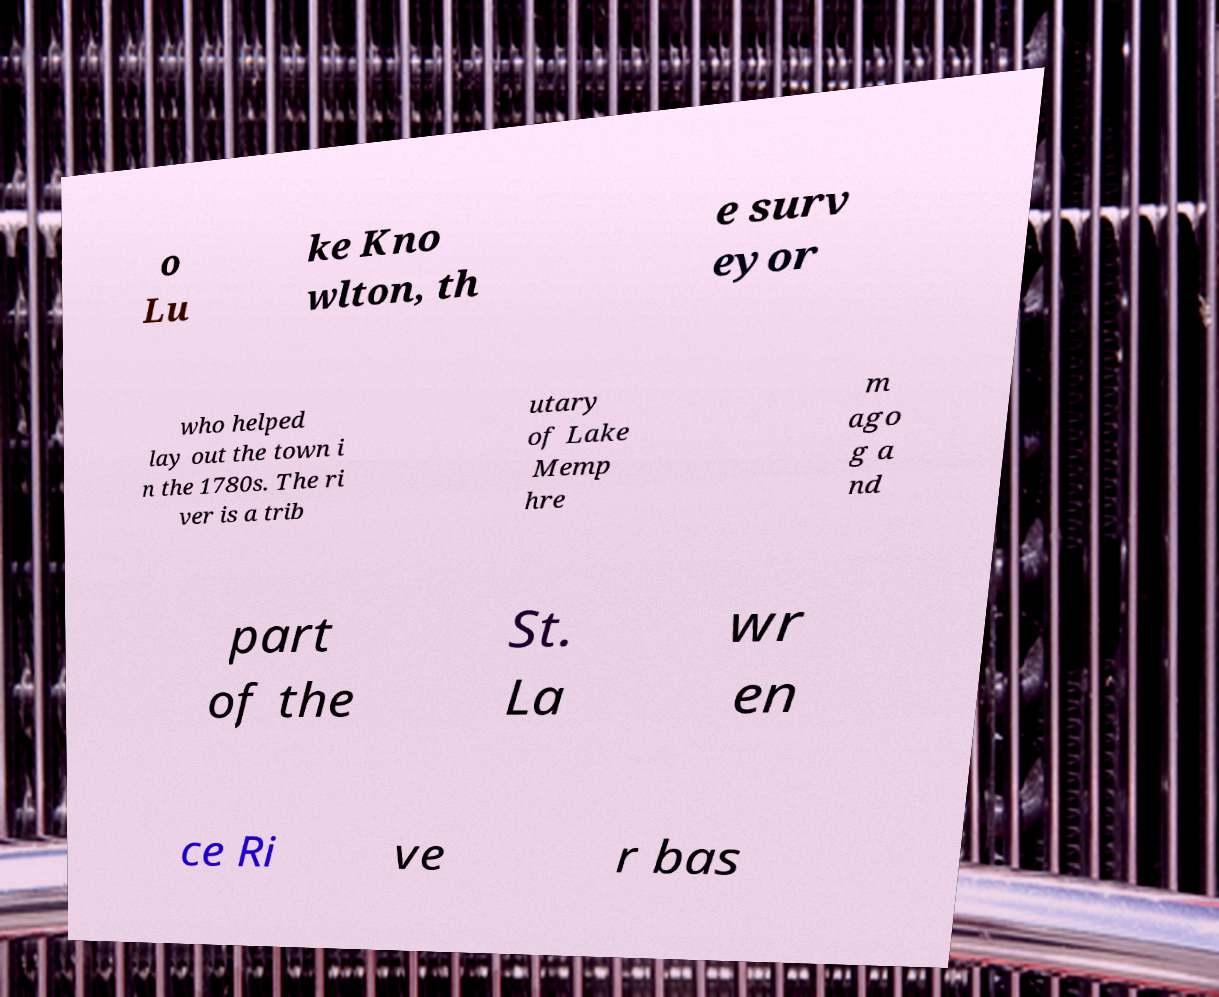Please identify and transcribe the text found in this image. o Lu ke Kno wlton, th e surv eyor who helped lay out the town i n the 1780s. The ri ver is a trib utary of Lake Memp hre m ago g a nd part of the St. La wr en ce Ri ve r bas 